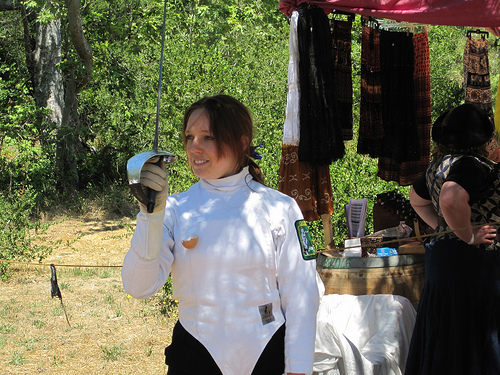<image>
Is there a girl next to the tree? No. The girl is not positioned next to the tree. They are located in different areas of the scene. 